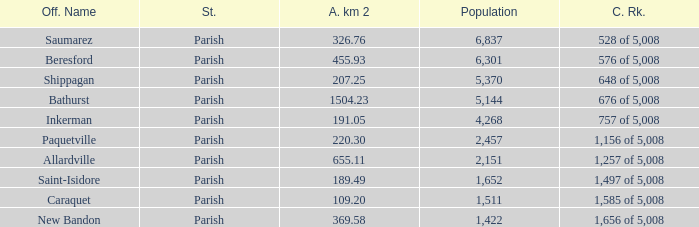What is the Area of the Allardville Parish with a Population smaller than 2,151? None. 